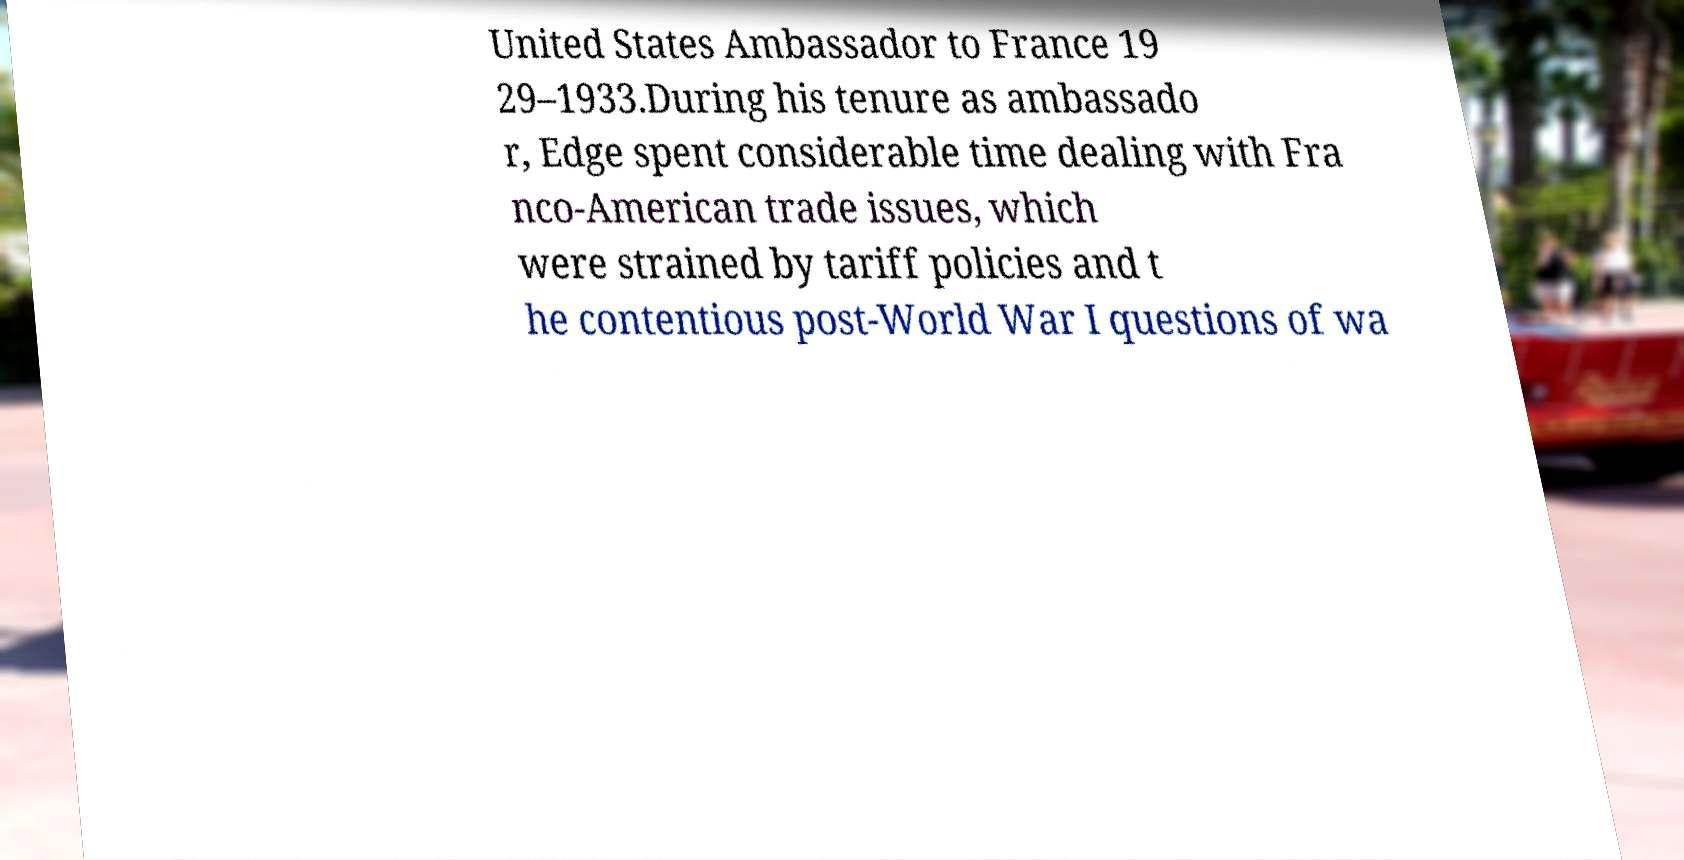For documentation purposes, I need the text within this image transcribed. Could you provide that? United States Ambassador to France 19 29–1933.During his tenure as ambassado r, Edge spent considerable time dealing with Fra nco-American trade issues, which were strained by tariff policies and t he contentious post-World War I questions of wa 